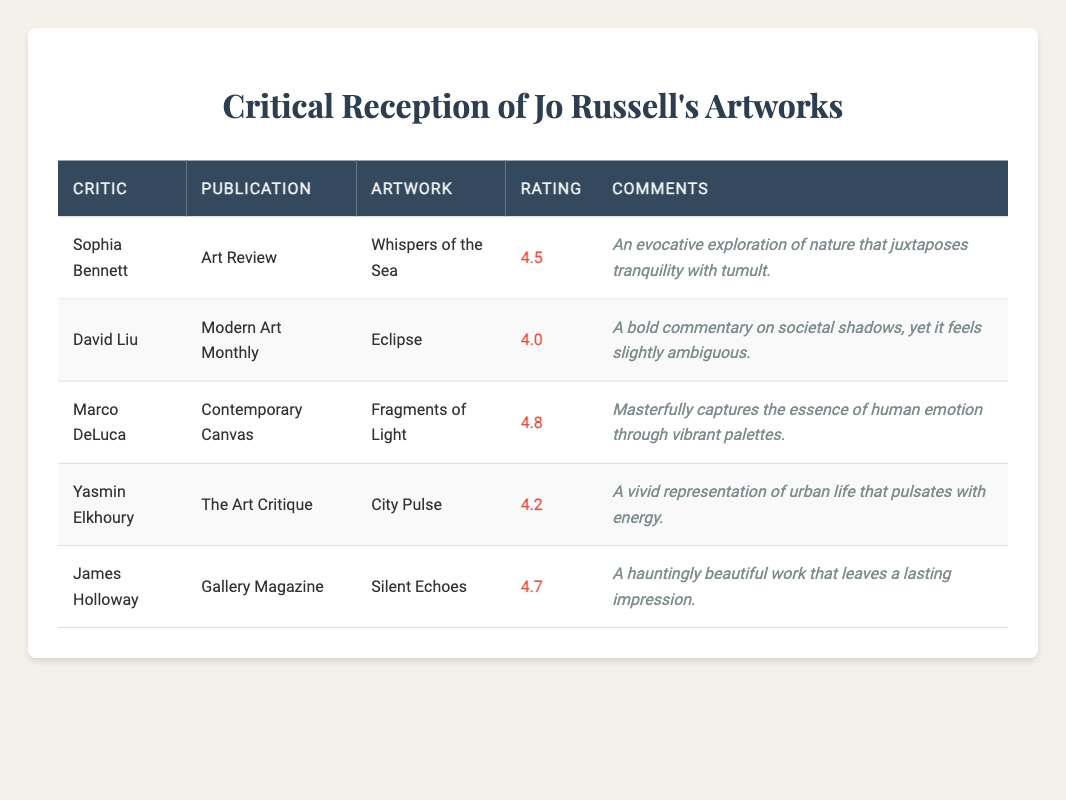What is the highest rating given to Jo Russell's artworks? The ratings for the artworks are 4.5, 4.0, 4.8, 4.2, and 4.7. The highest rating among these is 4.8 for "Fragments of Light".
Answer: 4.8 Which artwork received the lowest rating, and what was that rating? The ratings given in the table are 4.5, 4.0, 4.8, 4.2, and 4.7. The lowest rating is 4.0 for the artwork "Eclipse".
Answer: Eclipse, 4.0 Did any artwork receive a rating of 5.0? Upon reviewing the ratings of 4.5, 4.0, 4.8, 4.2, and 4.7, there is no artwork with a 5.0 rating mentioned in the table.
Answer: No What is the average rating of all the artworks reviewed by critics? First, we calculate the total ratings: 4.5 + 4.0 + 4.8 + 4.2 + 4.7 = 22.2. Then, divide this sum by the number of artworks, which is 5. This gives an average rating of 22.2 / 5 = 4.44.
Answer: 4.44 How many artworks had a rating of 4.5 or higher? The ratings of the artworks are 4.5, 4.0, 4.8, 4.2, and 4.7. The ratings that are 4.5 or higher are 4.5, 4.8, 4.2, and 4.7 which totals to 4 artworks.
Answer: 4 Was "City Pulse" rated higher than "Eclipse"? The rating for "City Pulse" is 4.2 and for "Eclipse" it is 4.0. Since 4.2 is greater than 4.0, "City Pulse" received a higher rating than "Eclipse".
Answer: Yes Which critic provided comments about the artwork that encapsulates human emotion? The table shows that Marco DeLuca provided comments on "Fragments of Light" which captured human emotion through vibrant palettes.
Answer: Marco DeLuca What is the difference in ratings between "Silent Echoes" and "Eclipse"? "Silent Echoes" has a rating of 4.7 and "Eclipse" has a rating of 4.0. To find the difference, subtract 4.0 from 4.7, resulting in 0.7.
Answer: 0.7 